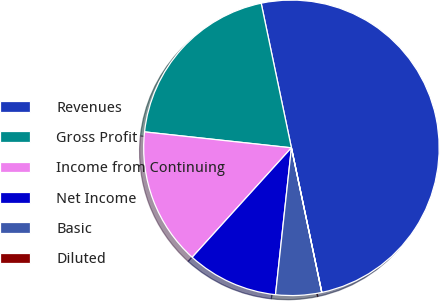<chart> <loc_0><loc_0><loc_500><loc_500><pie_chart><fcel>Revenues<fcel>Gross Profit<fcel>Income from Continuing<fcel>Net Income<fcel>Basic<fcel>Diluted<nl><fcel>49.98%<fcel>20.0%<fcel>15.0%<fcel>10.0%<fcel>5.01%<fcel>0.01%<nl></chart> 